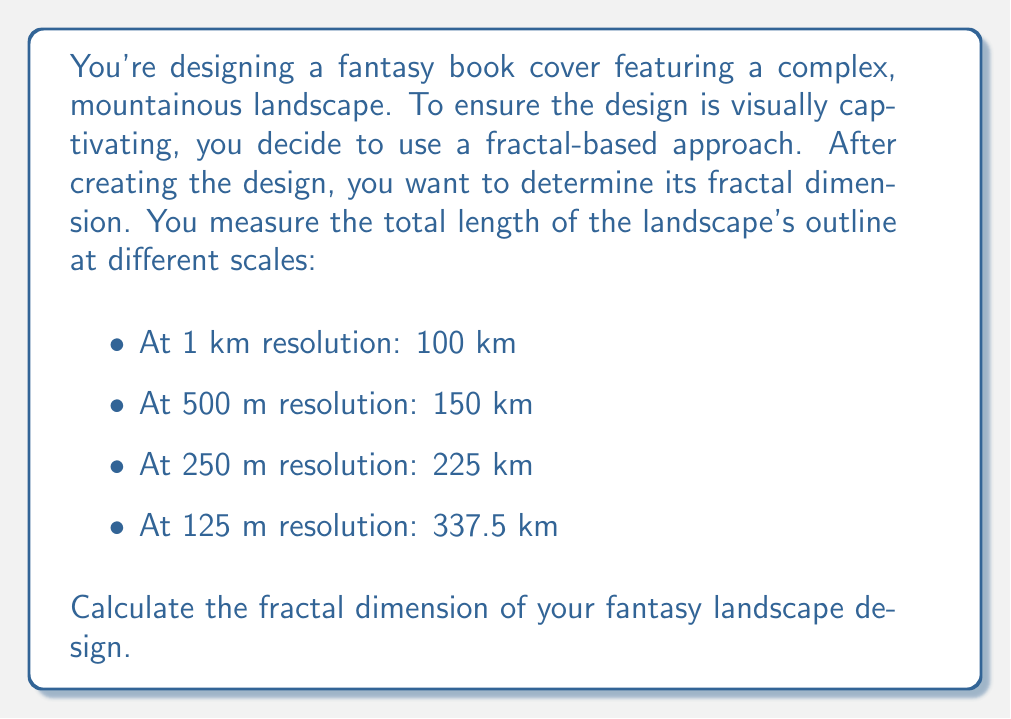Can you answer this question? To determine the fractal dimension of the landscape design, we'll use the box-counting method. The fractal dimension $D$ is given by the formula:

$$ D = -\frac{\log N(s)}{\log s} $$

Where $N(s)$ is the number of boxes of size $s$ needed to cover the object.

In our case, we have length measurements at different scales, so we'll use the relationship between length and scale:

$$ L(s) \propto s^{1-D} $$

Where $L(s)$ is the measured length at scale $s$.

Taking the logarithm of both sides:

$$ \log L(s) = (1-D) \log s + c $$

This is a linear equation where $(1-D)$ is the slope.

Let's create a table of $\log s$ and $\log L(s)$:

1. $s_1 = 1$ km, $L(s_1) = 100$ km: $\log s_1 = 0$, $\log L(s_1) = 2$
2. $s_2 = 0.5$ km, $L(s_2) = 150$ km: $\log s_2 = -0.301$, $\log L(s_2) = 2.176$
3. $s_3 = 0.25$ km, $L(s_3) = 225$ km: $\log s_3 = -0.602$, $\log L(s_3) = 2.352$
4. $s_4 = 0.125$ km, $L(s_4) = 337.5$ km: $\log s_4 = -0.903$, $\log L(s_4) = 2.528$

Now we can calculate the slope using the first and last points:

$$ \text{slope} = \frac{2.528 - 2}{-0.903 - 0} = -0.584 $$

Since $\text{slope} = 1-D$, we have:

$$ 1-D = -0.584 $$
$$ D = 1.584 $$

Therefore, the fractal dimension of the fantasy landscape design is approximately 1.584.
Answer: The fractal dimension of the fantasy landscape design is approximately 1.584. 